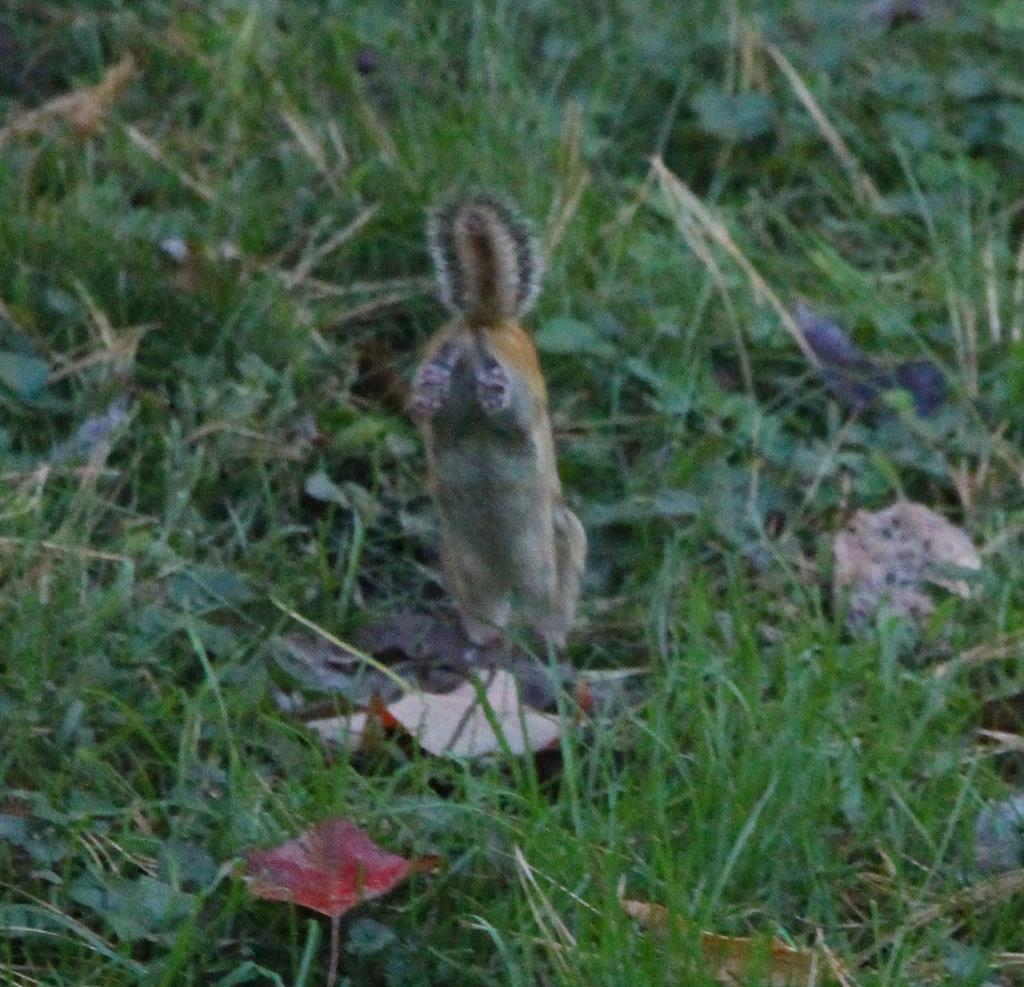What animal can be seen in the image? There is a squirrel in the image. Where is the squirrel located? The squirrel is in the grass. What else can be found in the grass in the image? There are leaves in the grass. What type of beef is being sold at the market in the image? There is no market or beef present in the image; it features a squirrel in the grass with leaves. 